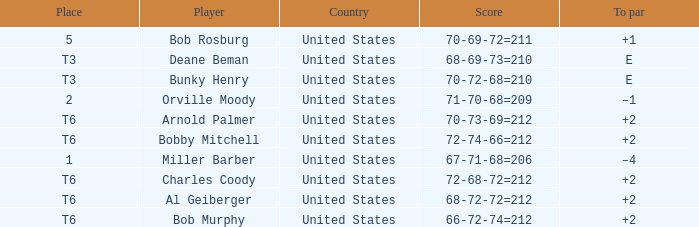Who is the participant with a t6 rank and a 72-68-72=212 score? Charles Coody. 